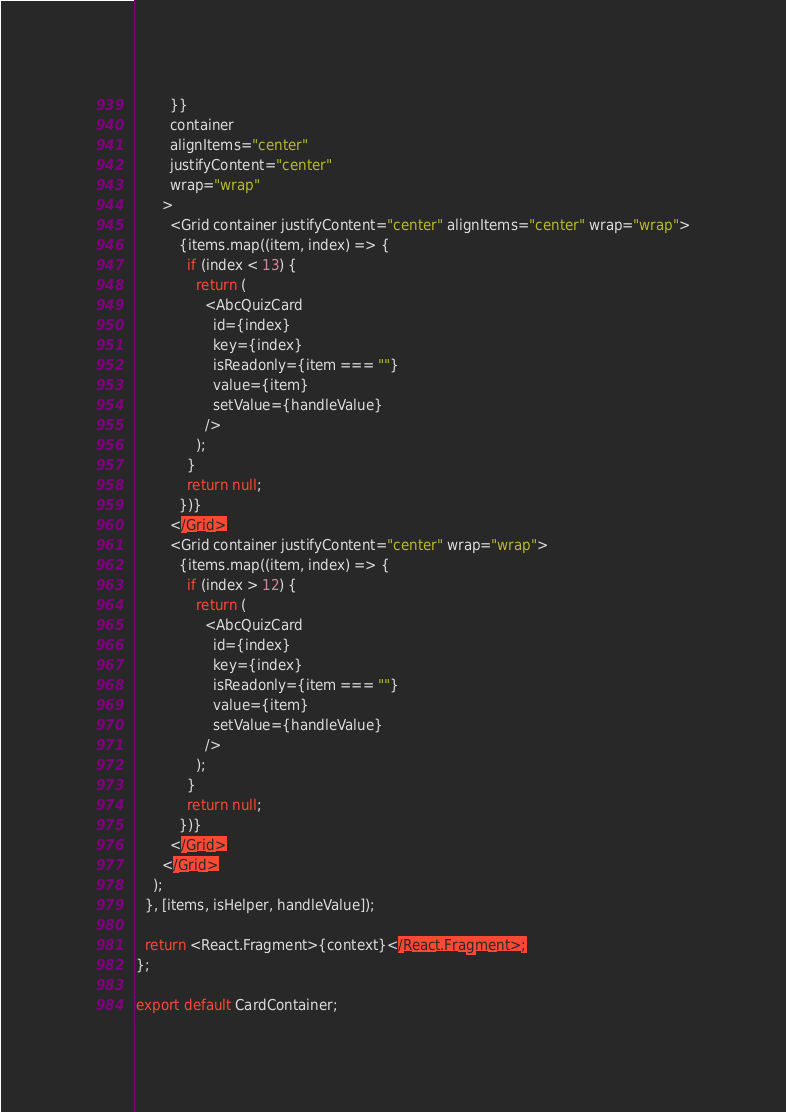<code> <loc_0><loc_0><loc_500><loc_500><_TypeScript_>        }}
        container
        alignItems="center"
        justifyContent="center"
        wrap="wrap"
      >
        <Grid container justifyContent="center" alignItems="center" wrap="wrap">
          {items.map((item, index) => {
            if (index < 13) {
              return (
                <AbcQuizCard
                  id={index}
                  key={index}
                  isReadonly={item === ""}
                  value={item}
                  setValue={handleValue}
                />
              );
            }
            return null;
          })}
        </Grid>
        <Grid container justifyContent="center" wrap="wrap">
          {items.map((item, index) => {
            if (index > 12) {
              return (
                <AbcQuizCard
                  id={index}
                  key={index}
                  isReadonly={item === ""}
                  value={item}
                  setValue={handleValue}
                />
              );
            }
            return null;
          })}
        </Grid>
      </Grid>
    );
  }, [items, isHelper, handleValue]);

  return <React.Fragment>{context}</React.Fragment>;
};

export default CardContainer;
</code> 